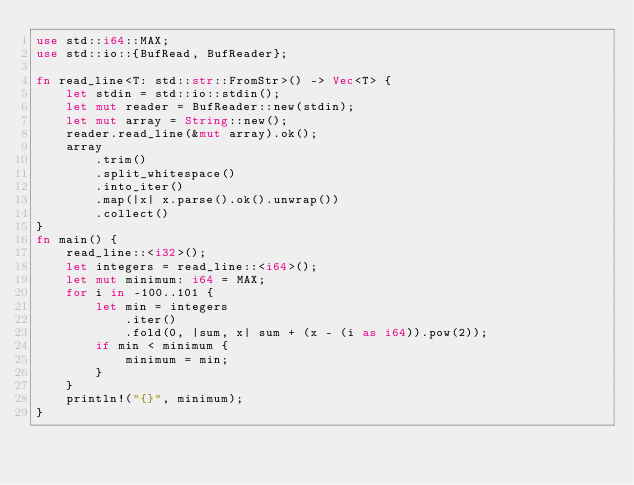Convert code to text. <code><loc_0><loc_0><loc_500><loc_500><_Rust_>use std::i64::MAX;
use std::io::{BufRead, BufReader};

fn read_line<T: std::str::FromStr>() -> Vec<T> {
    let stdin = std::io::stdin();
    let mut reader = BufReader::new(stdin);
    let mut array = String::new();
    reader.read_line(&mut array).ok();
    array
        .trim()
        .split_whitespace()
        .into_iter()
        .map(|x| x.parse().ok().unwrap())
        .collect()
}
fn main() {
    read_line::<i32>();
    let integers = read_line::<i64>();
    let mut minimum: i64 = MAX;
    for i in -100..101 {
        let min = integers
            .iter()
            .fold(0, |sum, x| sum + (x - (i as i64)).pow(2));
        if min < minimum {
            minimum = min;
        }
    }
    println!("{}", minimum);
}
</code> 